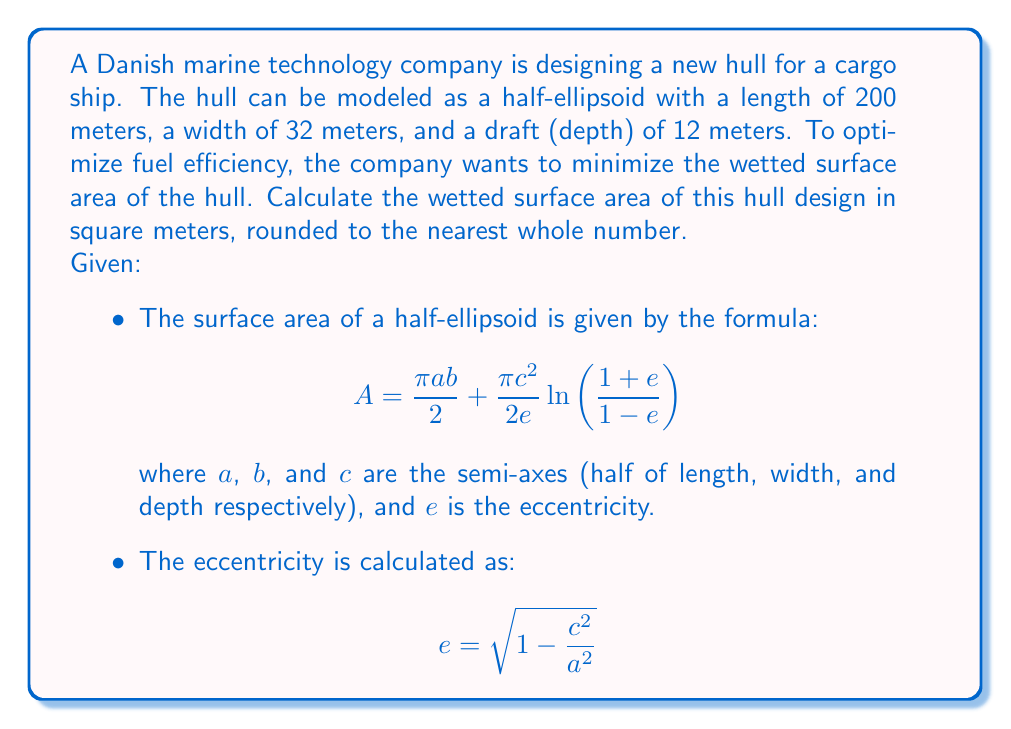Can you solve this math problem? To solve this problem, we'll follow these steps:

1. Identify the semi-axes:
   $a = 100$ m (half of length)
   $b = 16$ m (half of width)
   $c = 12$ m (depth)

2. Calculate the eccentricity $e$:
   $$e = \sqrt{1 - \frac{c^2}{a^2}} = \sqrt{1 - \frac{12^2}{100^2}} = \sqrt{1 - 0.0144} = \sqrt{0.9856} \approx 0.9928$$

3. Calculate the surface area using the given formula:
   $$A = \frac{\pi ab}{2} + \frac{\pi c^2}{2e}\ln\left(\frac{1+e}{1-e}\right)$$

   Substituting the values:
   $$A = \frac{\pi \cdot 100 \cdot 16}{2} + \frac{\pi \cdot 12^2}{2 \cdot 0.9928}\ln\left(\frac{1+0.9928}{1-0.9928}\right)$$

4. Evaluate each part separately:
   Part 1: $\frac{\pi \cdot 100 \cdot 16}{2} = 2513.27$ m²

   Part 2: 
   $\frac{\pi \cdot 12^2}{2 \cdot 0.9928} = 227.33$ m²
   $\ln\left(\frac{1+0.9928}{1-0.9928}\right) = \ln(191.67) = 5.26$

   $227.33 \cdot 5.26 = 1195.76$ m²

5. Sum the parts:
   $A = 2513.27 + 1195.76 = 3709.03$ m²

6. Round to the nearest whole number:
   $A \approx 3709$ m²
Answer: 3709 m² 